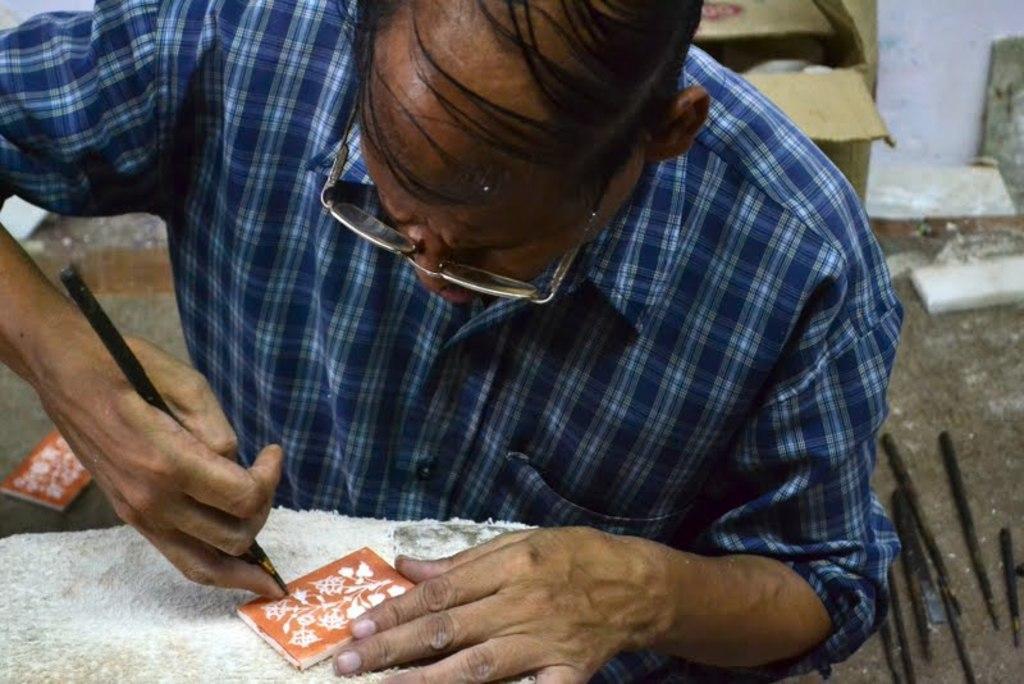Can you describe this image briefly? In this image we can see a person is holding an object with his hands. Here we can see stones, cloth, wall, and few objects. 